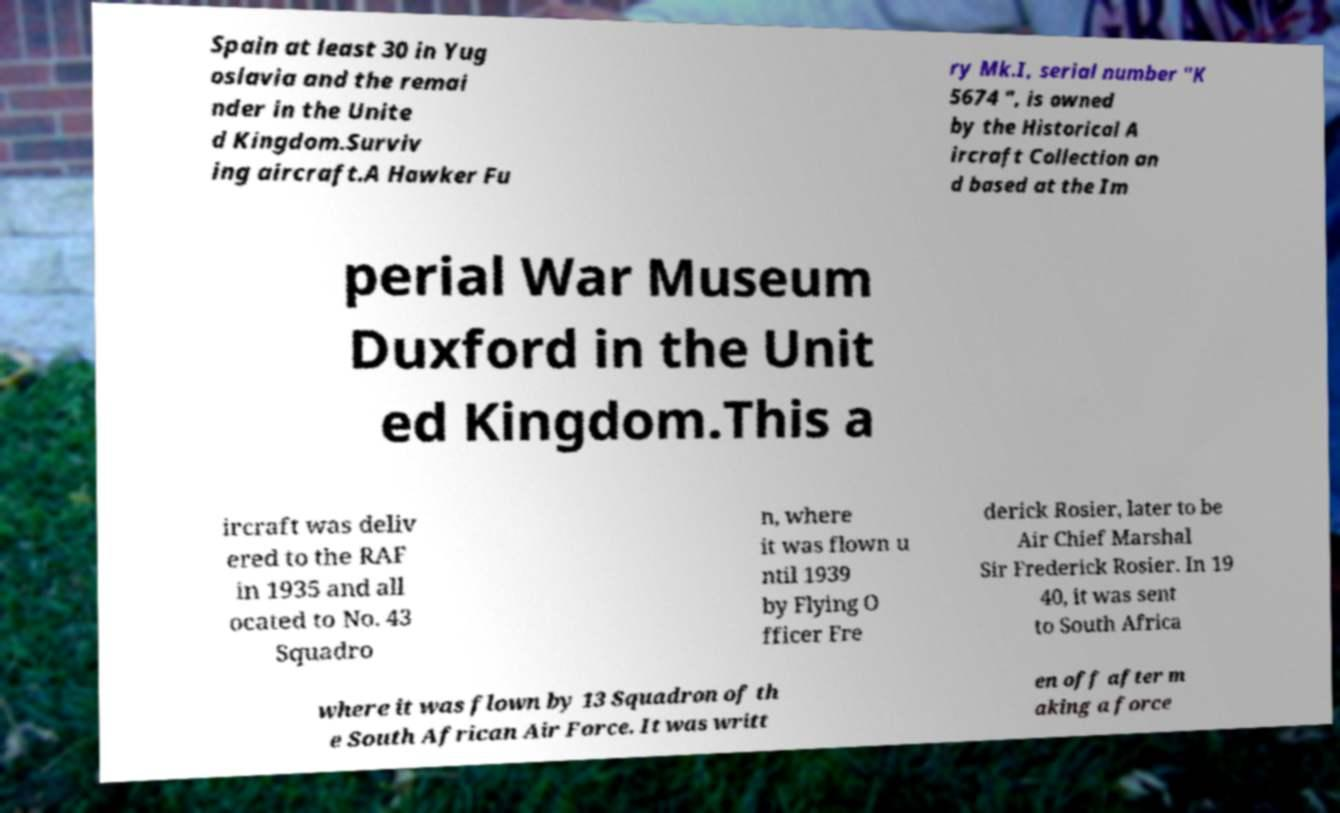Can you read and provide the text displayed in the image?This photo seems to have some interesting text. Can you extract and type it out for me? Spain at least 30 in Yug oslavia and the remai nder in the Unite d Kingdom.Surviv ing aircraft.A Hawker Fu ry Mk.I, serial number "K 5674 ", is owned by the Historical A ircraft Collection an d based at the Im perial War Museum Duxford in the Unit ed Kingdom.This a ircraft was deliv ered to the RAF in 1935 and all ocated to No. 43 Squadro n, where it was flown u ntil 1939 by Flying O fficer Fre derick Rosier, later to be Air Chief Marshal Sir Frederick Rosier. In 19 40, it was sent to South Africa where it was flown by 13 Squadron of th e South African Air Force. It was writt en off after m aking a force 